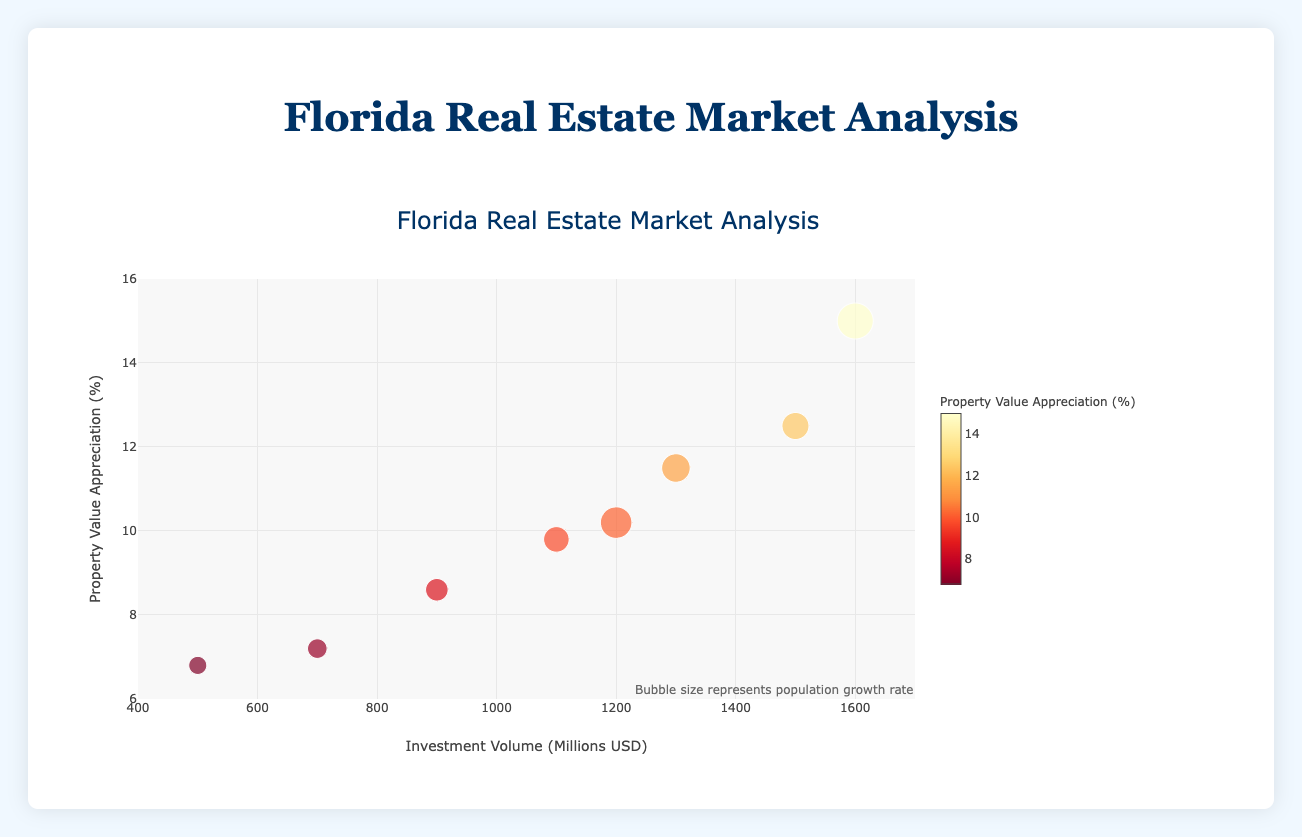What is the title of the bubble chart? The title of the bubble chart is clearly indicated at the top of the plot. It is designed to give an overview of the subject of the visualization.
Answer: Florida Real Estate Market Analysis How is the horizontal axis labeled? The horizontal axis label can be found below the horizontal line that runs from left to right. It provides information on what the x-values represent in the chart.
Answer: Investment Volume (Millions USD) Which city has the highest property value appreciation? The city with the highest property value appreciation will have the highest y-coordinate on the vertical axis. Looking at this point, we can identify the corresponding city from the legend or plot labels.
Answer: Naples What's the range of the population growth rate used to determine the bubble sizes? The population growth rate is visually represented by the size of the bubbles. Examining the smallest and largest bubbles on the plot provides the range of values.
Answer: 1.2% to 2.4% How does Sarasota compare to Miami in terms of investment volume? To compare Sarasota and Miami in terms of investment volume, we look at the x-coordinates of the corresponding bubbles. Sarasota has a lower x-coordinate compared to Miami, indicating a lower investment volume.
Answer: Sarasota has less investment volume than Miami Considering all cities, which one has the lowest property value appreciation and what is that value? To find the city with the lowest property value appreciation, we locate the bubble with the lowest y-coordinate. Then, we refer to the bubble's annotation or hover tool for the specific value.
Answer: Gainesville, with 6.8% Which city shows a relatively high population growth rate but moderate investment volume? By observing the size of the bubbles (indicating population growth rate) and the x-coordinates (investment volume), we identify a city with a large bubble at a moderate x-coordinate position.
Answer: Orlando How are the bubble colors determined in the chart? The bubble colors are determined based on the property value appreciation, with a color scale shown on the right side of the chart. The scale ranges from lighter to darker shades as property value appreciation increases.
Answer: Based on property value appreciation What is the trend between investment volume and property value appreciation considering all cities? To assess the trend between investment volume and property value appreciation, we observe the general direction of the data points. They generally form an upward trend, indicating a positive relationship between investment volume and property value appreciation.
Answer: Positive trend 